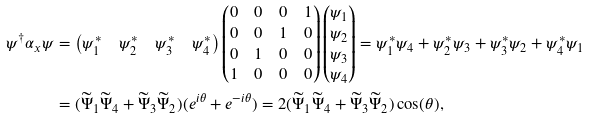Convert formula to latex. <formula><loc_0><loc_0><loc_500><loc_500>\psi ^ { \dagger } \alpha _ { x } \psi & = \left ( \begin{matrix} \psi _ { 1 } ^ { \ast } & \psi _ { 2 } ^ { \ast } & \psi _ { 3 } ^ { \ast } & \psi _ { 4 } ^ { \ast } \end{matrix} \right ) \left ( \begin{matrix} 0 & 0 & 0 & 1 \\ 0 & 0 & 1 & 0 \\ 0 & 1 & 0 & 0 \\ 1 & 0 & 0 & 0 \end{matrix} \right ) \left ( \begin{matrix} \psi _ { 1 } \\ \psi _ { 2 } \\ \psi _ { 3 } \\ \psi _ { 4 } \end{matrix} \right ) = \psi _ { 1 } ^ { \ast } \psi _ { 4 } + \psi _ { 2 } ^ { \ast } \psi _ { 3 } + \psi _ { 3 } ^ { \ast } \psi _ { 2 } + \psi _ { 4 } ^ { \ast } \psi _ { 1 } \\ & = ( \widetilde { \Psi } _ { 1 } \widetilde { \Psi } _ { 4 } + \widetilde { \Psi } _ { 3 } \widetilde { \Psi } _ { 2 } ) ( e ^ { i \theta } + e ^ { - i \theta } ) = 2 ( \widetilde { \Psi } _ { 1 } \widetilde { \Psi } _ { 4 } + \widetilde { \Psi } _ { 3 } \widetilde { \Psi } _ { 2 } ) \cos ( \theta ) ,</formula> 